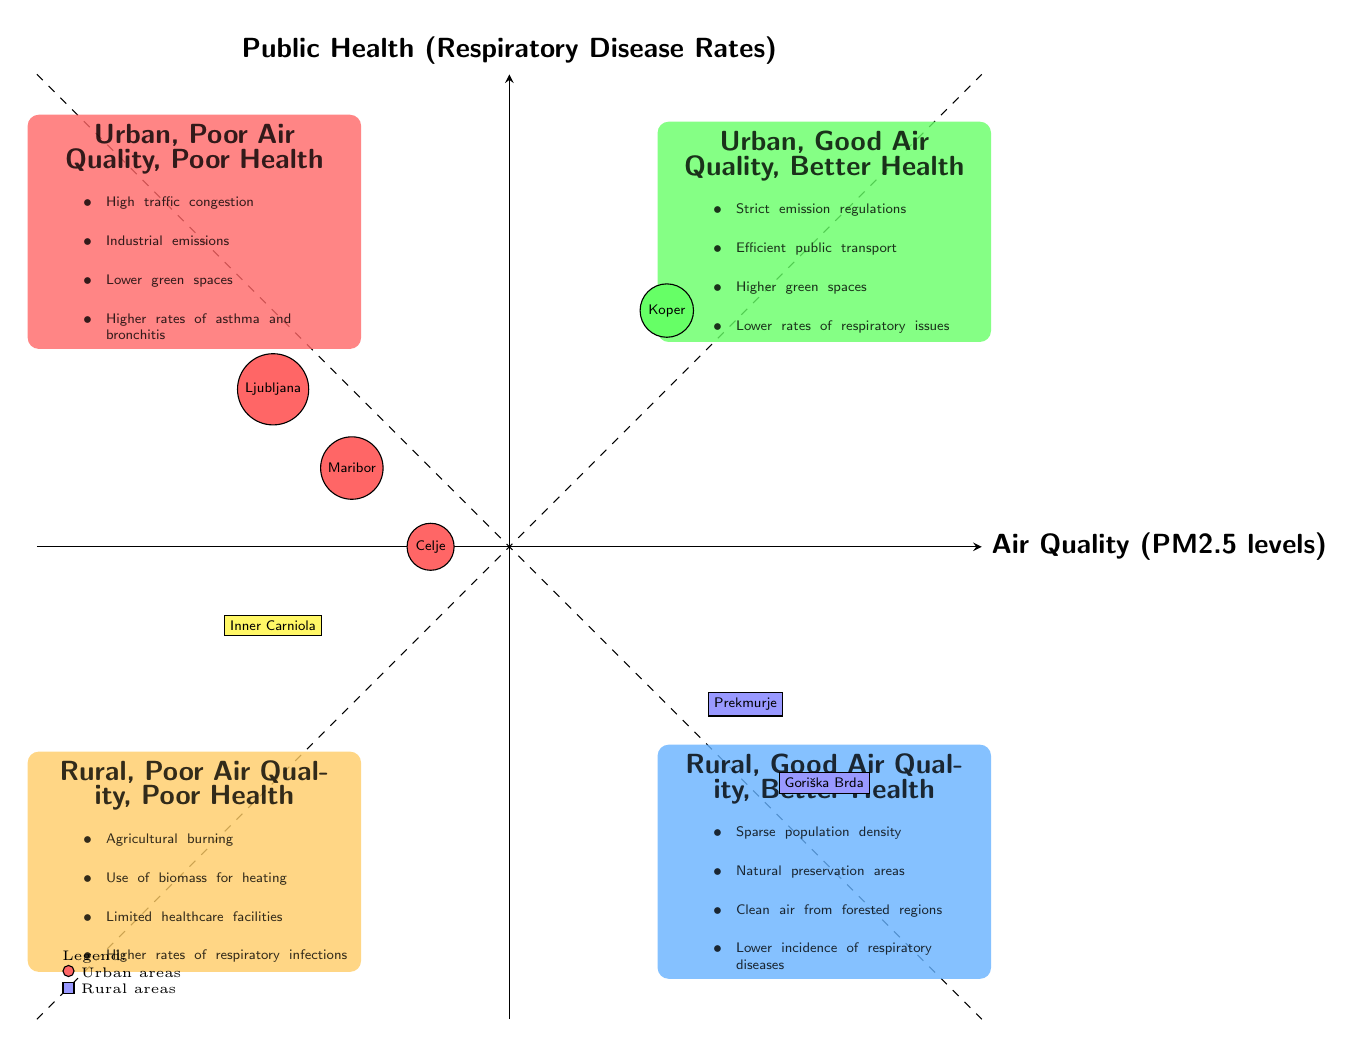What are the characteristics of the "Urban, Poor Air Quality, Poor Health" quadrant? This quadrant displays characteristics such as high traffic congestion, industrial emissions, lower green spaces, and higher rates of asthma and bronchitis. These details are outlined specifically within the quadrant's description.
Answer: High traffic congestion, industrial emissions, lower green spaces, higher rates of asthma and bronchitis Which urban area is identified in the "Urban, Good Air Quality, Better Health" quadrant? The urban area indicated in this quadrant is Koper, which is visually represented with a green circle in the upper right quadrant.
Answer: Koper What are the public health rates like in "Rural, Good Air Quality, Better Health"? This quadrant indicates lower incidence of respiratory diseases as one of its defining characteristics. It's a key aspect highlighted in its description.
Answer: Lower incidence of respiratory diseases How many cities are represented within the quadrants? The diagram shows a total of four cities: Ljubljana, Maribor, Celje, and Koper, which can be counted through the listed urban nodes in the diagram.
Answer: 4 What does the "Rural, Poor Air Quality, Poor Health" quadrant suggest about healthcare facilities? It states that there are limited healthcare facilities in this quadrant, which is mentioned as one of the characteristics associated with this specific condition.
Answer: Limited healthcare facilities Which rural area is represented in the "Rural, Good Air Quality, Better Health" quadrant? Prekmurje is the rural area marked within this quadrant, shown as a blue rectangle located in the lower right section of the chart.
Answer: Prekmurje What is the relationship between air quality and public health in urban areas with poor air quality? In urban areas with poor air quality, there is a noted correlation with poor health outcomes, as evidenced by higher rates of respiratory diseases, indicated in the respective quadrant.
Answer: Poor health outcomes How does the population density in the "Rural, Good Air Quality, Better Health" quadrant affect air quality? This quadrant highlights sparse population density as a characteristic, which correlates with good air quality due to reduced pollution and urban activities.
Answer: Reduced pollution 